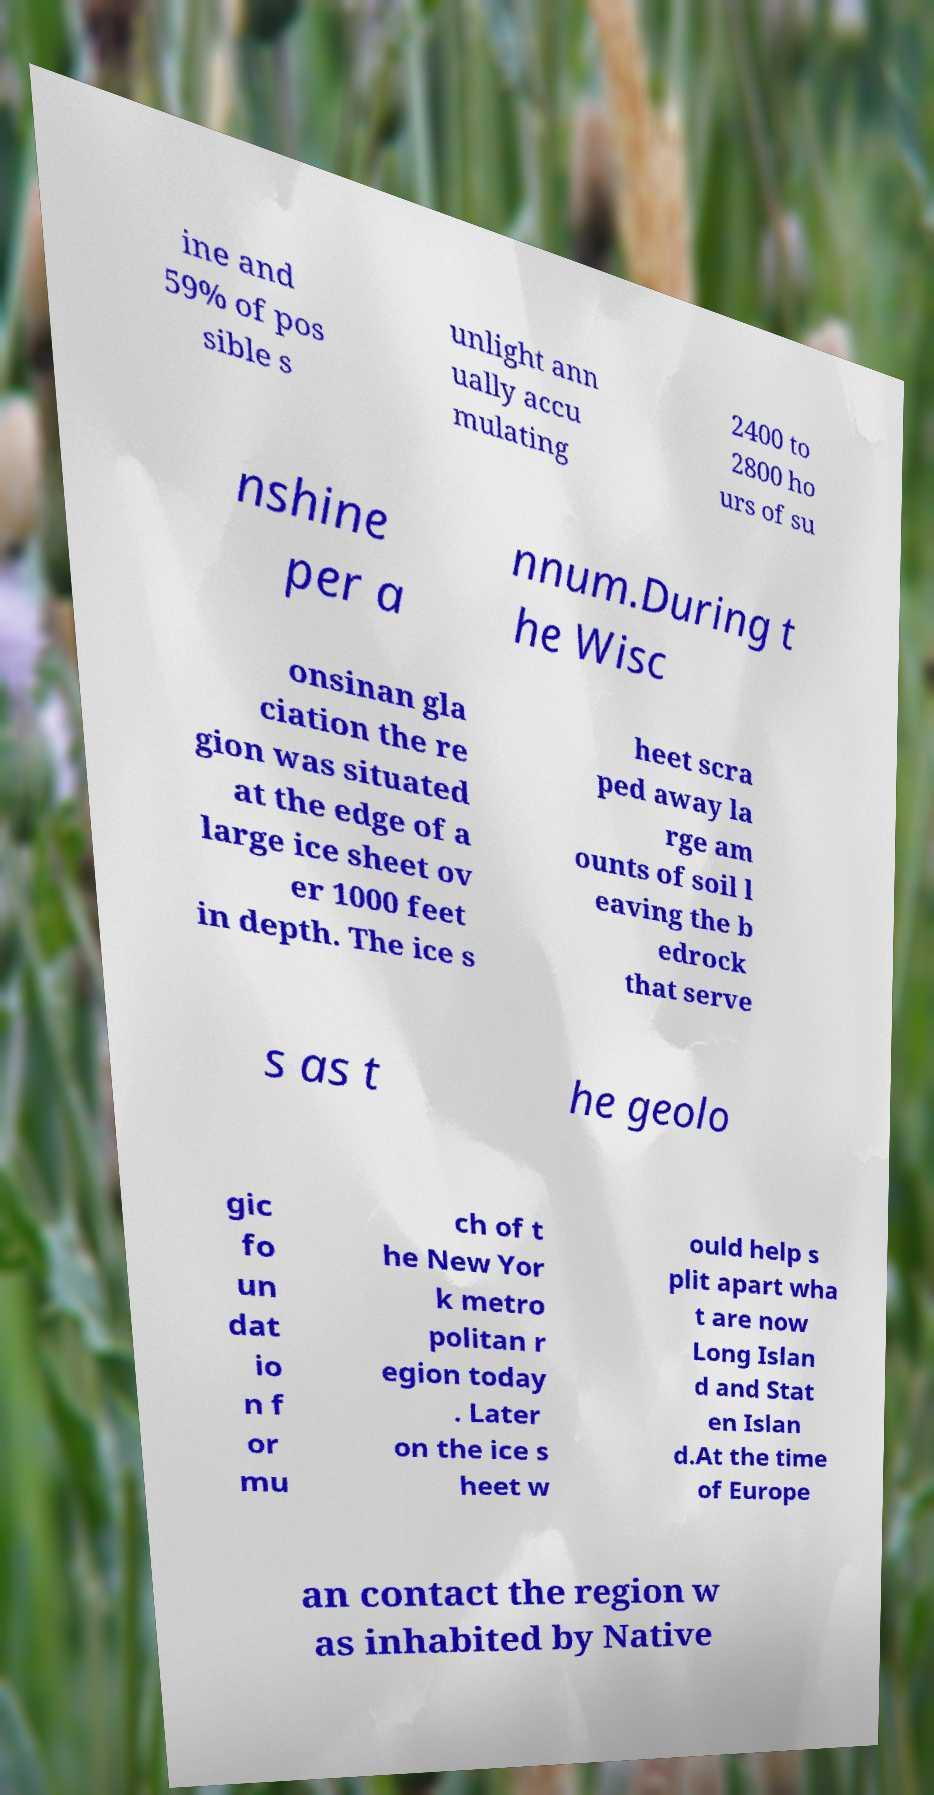Please identify and transcribe the text found in this image. ine and 59% of pos sible s unlight ann ually accu mulating 2400 to 2800 ho urs of su nshine per a nnum.During t he Wisc onsinan gla ciation the re gion was situated at the edge of a large ice sheet ov er 1000 feet in depth. The ice s heet scra ped away la rge am ounts of soil l eaving the b edrock that serve s as t he geolo gic fo un dat io n f or mu ch of t he New Yor k metro politan r egion today . Later on the ice s heet w ould help s plit apart wha t are now Long Islan d and Stat en Islan d.At the time of Europe an contact the region w as inhabited by Native 